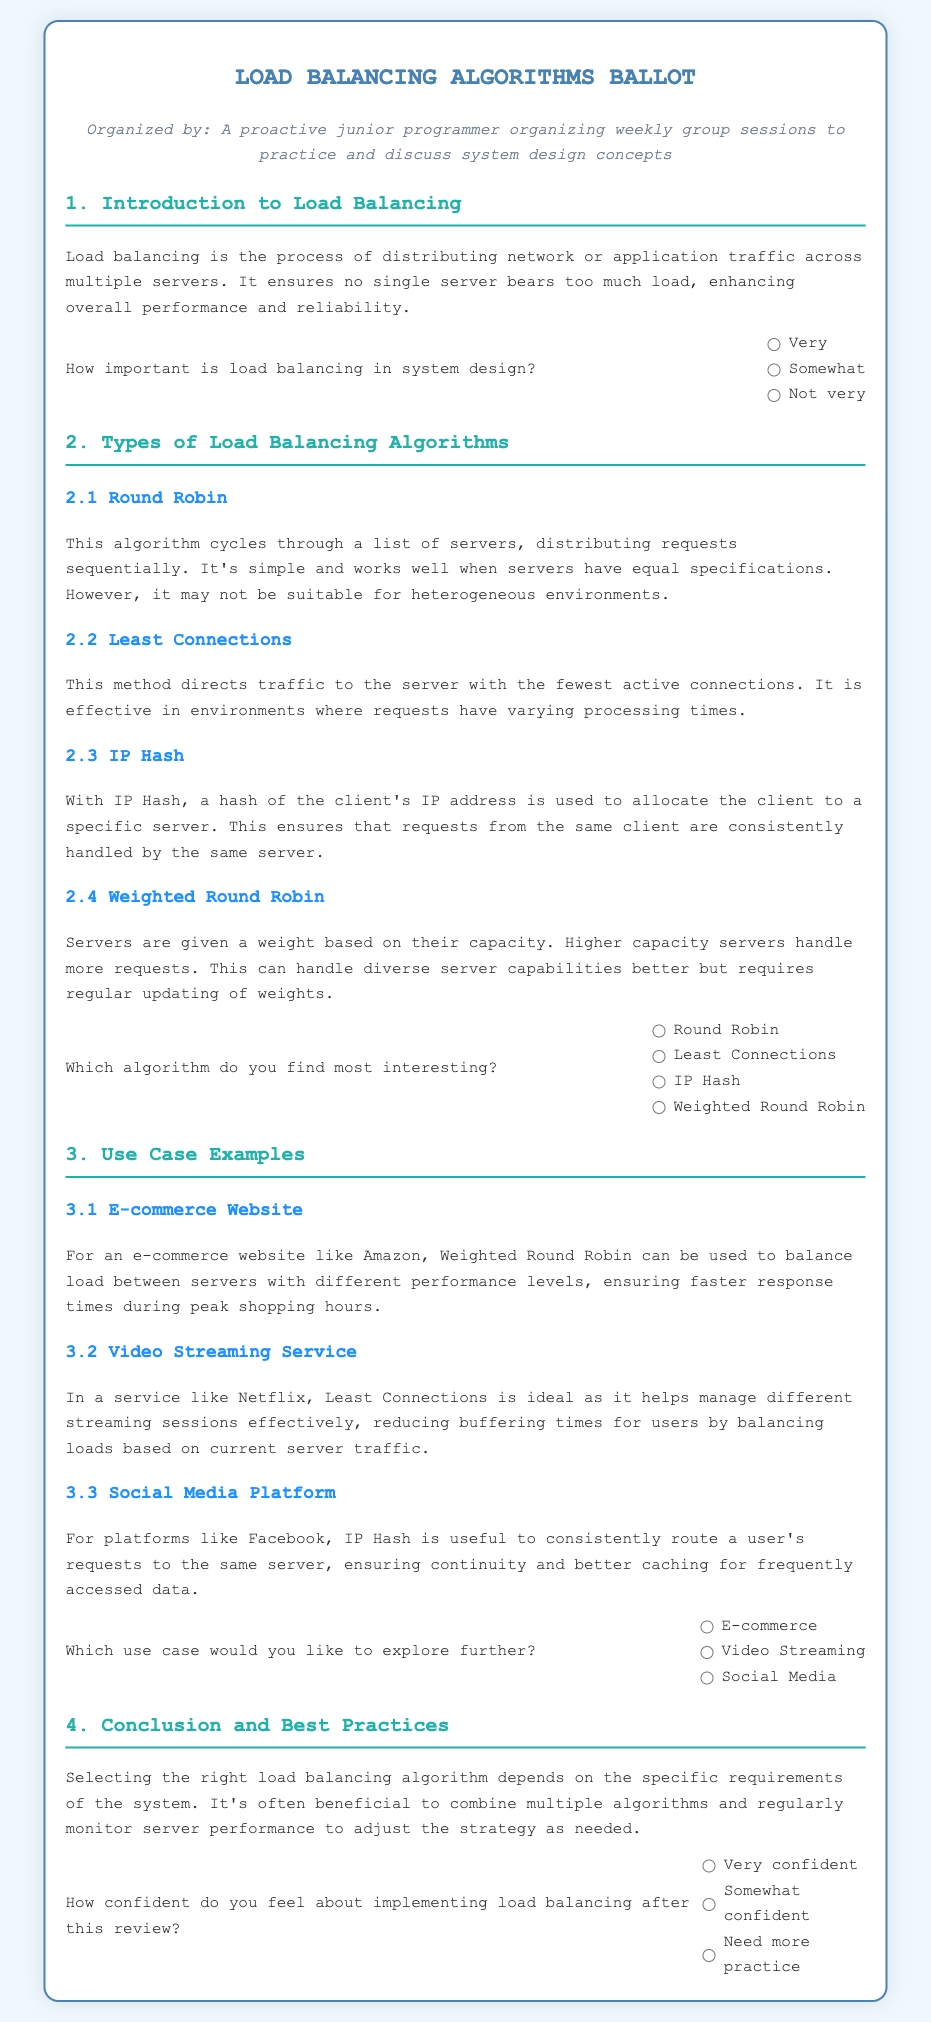How important is load balancing in system design? This question refers to the importance of load balancing as described in the introduction section of the document.
Answer: Very Which algorithm do you find most interesting? This question is related to the options provided under the types of load balancing algorithms discussed in the document.
Answer: Round Robin What is the algorithm that uses the fewest active connections? This refers to the specific algorithm mentioned that directs traffic based on the number of active connections.
Answer: Least Connections What e-commerce site example is given for using Weighted Round Robin? This asks for the specific example provided in the use case section that illustrates the application of a particular algorithm.
Answer: Amazon Which use case would you like to explore further? This question pertains to the use cases outlined in the document, asking for a preference for further exploration.
Answer: E-commerce How confident do you feel about implementing load balancing after this review? This question pertains to the confidence levels expressed in response to learning about load balancing algorithms.
Answer: Very confident 